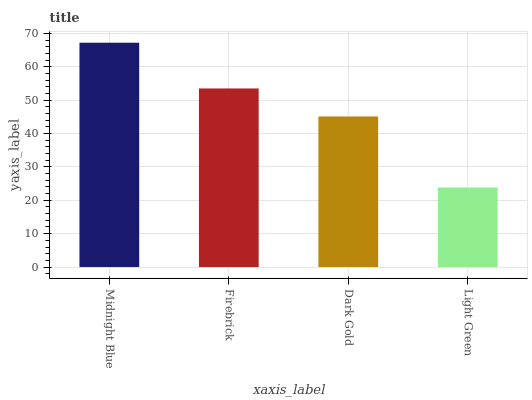Is Light Green the minimum?
Answer yes or no. Yes. Is Midnight Blue the maximum?
Answer yes or no. Yes. Is Firebrick the minimum?
Answer yes or no. No. Is Firebrick the maximum?
Answer yes or no. No. Is Midnight Blue greater than Firebrick?
Answer yes or no. Yes. Is Firebrick less than Midnight Blue?
Answer yes or no. Yes. Is Firebrick greater than Midnight Blue?
Answer yes or no. No. Is Midnight Blue less than Firebrick?
Answer yes or no. No. Is Firebrick the high median?
Answer yes or no. Yes. Is Dark Gold the low median?
Answer yes or no. Yes. Is Midnight Blue the high median?
Answer yes or no. No. Is Light Green the low median?
Answer yes or no. No. 